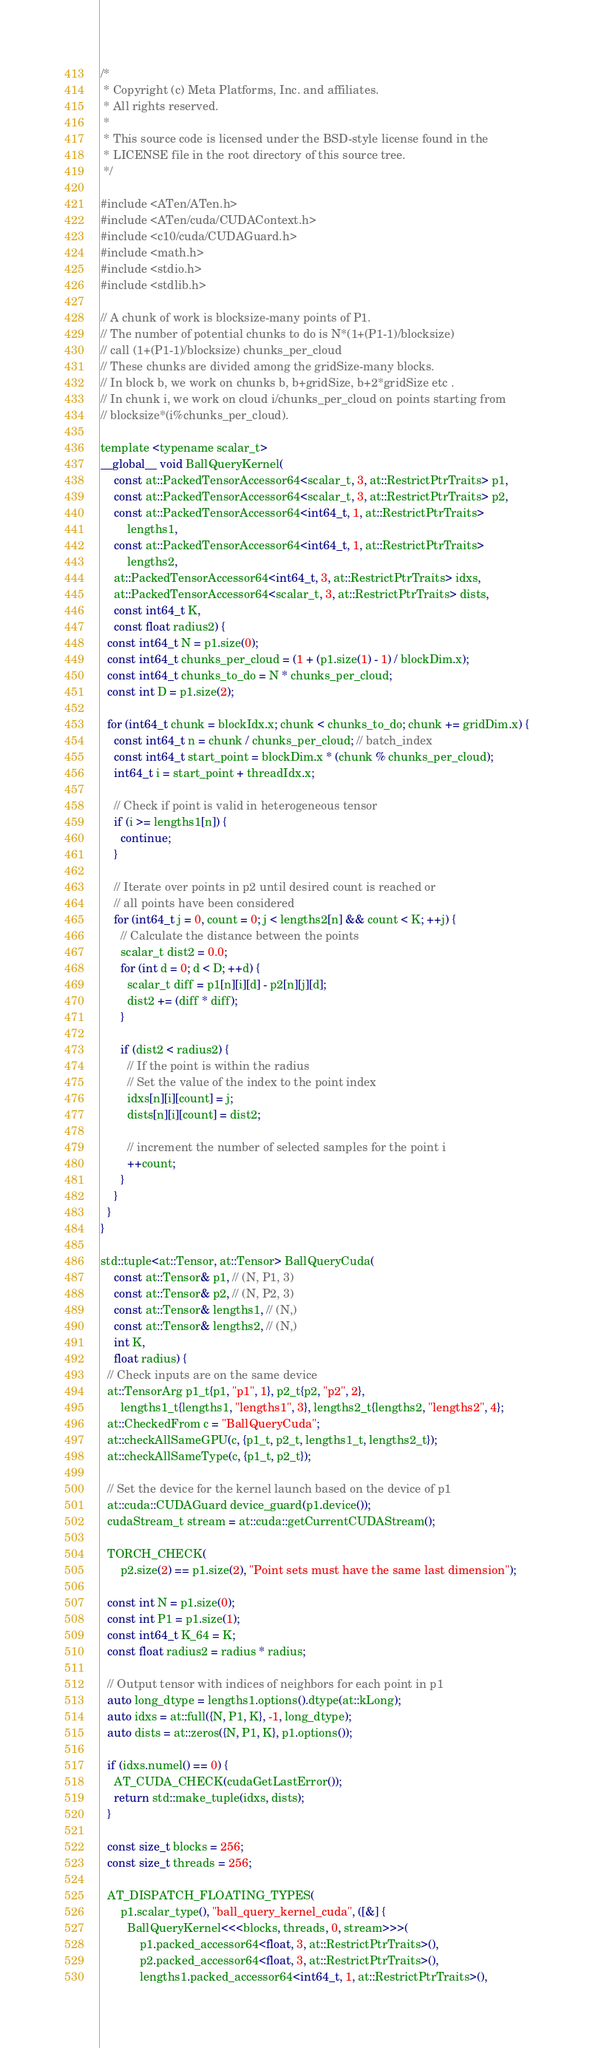Convert code to text. <code><loc_0><loc_0><loc_500><loc_500><_Cuda_>/*
 * Copyright (c) Meta Platforms, Inc. and affiliates.
 * All rights reserved.
 *
 * This source code is licensed under the BSD-style license found in the
 * LICENSE file in the root directory of this source tree.
 */

#include <ATen/ATen.h>
#include <ATen/cuda/CUDAContext.h>
#include <c10/cuda/CUDAGuard.h>
#include <math.h>
#include <stdio.h>
#include <stdlib.h>

// A chunk of work is blocksize-many points of P1.
// The number of potential chunks to do is N*(1+(P1-1)/blocksize)
// call (1+(P1-1)/blocksize) chunks_per_cloud
// These chunks are divided among the gridSize-many blocks.
// In block b, we work on chunks b, b+gridSize, b+2*gridSize etc .
// In chunk i, we work on cloud i/chunks_per_cloud on points starting from
// blocksize*(i%chunks_per_cloud).

template <typename scalar_t>
__global__ void BallQueryKernel(
    const at::PackedTensorAccessor64<scalar_t, 3, at::RestrictPtrTraits> p1,
    const at::PackedTensorAccessor64<scalar_t, 3, at::RestrictPtrTraits> p2,
    const at::PackedTensorAccessor64<int64_t, 1, at::RestrictPtrTraits>
        lengths1,
    const at::PackedTensorAccessor64<int64_t, 1, at::RestrictPtrTraits>
        lengths2,
    at::PackedTensorAccessor64<int64_t, 3, at::RestrictPtrTraits> idxs,
    at::PackedTensorAccessor64<scalar_t, 3, at::RestrictPtrTraits> dists,
    const int64_t K,
    const float radius2) {
  const int64_t N = p1.size(0);
  const int64_t chunks_per_cloud = (1 + (p1.size(1) - 1) / blockDim.x);
  const int64_t chunks_to_do = N * chunks_per_cloud;
  const int D = p1.size(2);

  for (int64_t chunk = blockIdx.x; chunk < chunks_to_do; chunk += gridDim.x) {
    const int64_t n = chunk / chunks_per_cloud; // batch_index
    const int64_t start_point = blockDim.x * (chunk % chunks_per_cloud);
    int64_t i = start_point + threadIdx.x;

    // Check if point is valid in heterogeneous tensor
    if (i >= lengths1[n]) {
      continue;
    }

    // Iterate over points in p2 until desired count is reached or
    // all points have been considered
    for (int64_t j = 0, count = 0; j < lengths2[n] && count < K; ++j) {
      // Calculate the distance between the points
      scalar_t dist2 = 0.0;
      for (int d = 0; d < D; ++d) {
        scalar_t diff = p1[n][i][d] - p2[n][j][d];
        dist2 += (diff * diff);
      }

      if (dist2 < radius2) {
        // If the point is within the radius
        // Set the value of the index to the point index
        idxs[n][i][count] = j;
        dists[n][i][count] = dist2;

        // increment the number of selected samples for the point i
        ++count;
      }
    }
  }
}

std::tuple<at::Tensor, at::Tensor> BallQueryCuda(
    const at::Tensor& p1, // (N, P1, 3)
    const at::Tensor& p2, // (N, P2, 3)
    const at::Tensor& lengths1, // (N,)
    const at::Tensor& lengths2, // (N,)
    int K,
    float radius) {
  // Check inputs are on the same device
  at::TensorArg p1_t{p1, "p1", 1}, p2_t{p2, "p2", 2},
      lengths1_t{lengths1, "lengths1", 3}, lengths2_t{lengths2, "lengths2", 4};
  at::CheckedFrom c = "BallQueryCuda";
  at::checkAllSameGPU(c, {p1_t, p2_t, lengths1_t, lengths2_t});
  at::checkAllSameType(c, {p1_t, p2_t});

  // Set the device for the kernel launch based on the device of p1
  at::cuda::CUDAGuard device_guard(p1.device());
  cudaStream_t stream = at::cuda::getCurrentCUDAStream();

  TORCH_CHECK(
      p2.size(2) == p1.size(2), "Point sets must have the same last dimension");

  const int N = p1.size(0);
  const int P1 = p1.size(1);
  const int64_t K_64 = K;
  const float radius2 = radius * radius;

  // Output tensor with indices of neighbors for each point in p1
  auto long_dtype = lengths1.options().dtype(at::kLong);
  auto idxs = at::full({N, P1, K}, -1, long_dtype);
  auto dists = at::zeros({N, P1, K}, p1.options());

  if (idxs.numel() == 0) {
    AT_CUDA_CHECK(cudaGetLastError());
    return std::make_tuple(idxs, dists);
  }

  const size_t blocks = 256;
  const size_t threads = 256;

  AT_DISPATCH_FLOATING_TYPES(
      p1.scalar_type(), "ball_query_kernel_cuda", ([&] {
        BallQueryKernel<<<blocks, threads, 0, stream>>>(
            p1.packed_accessor64<float, 3, at::RestrictPtrTraits>(),
            p2.packed_accessor64<float, 3, at::RestrictPtrTraits>(),
            lengths1.packed_accessor64<int64_t, 1, at::RestrictPtrTraits>(),</code> 